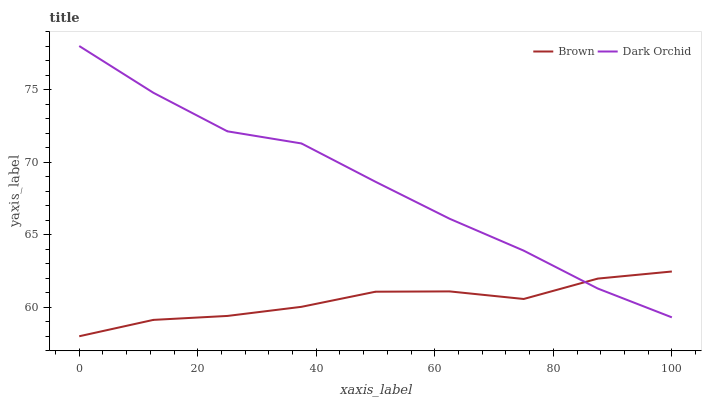Does Brown have the minimum area under the curve?
Answer yes or no. Yes. Does Dark Orchid have the maximum area under the curve?
Answer yes or no. Yes. Does Dark Orchid have the minimum area under the curve?
Answer yes or no. No. Is Dark Orchid the smoothest?
Answer yes or no. Yes. Is Brown the roughest?
Answer yes or no. Yes. Is Dark Orchid the roughest?
Answer yes or no. No. Does Brown have the lowest value?
Answer yes or no. Yes. Does Dark Orchid have the lowest value?
Answer yes or no. No. Does Dark Orchid have the highest value?
Answer yes or no. Yes. Does Brown intersect Dark Orchid?
Answer yes or no. Yes. Is Brown less than Dark Orchid?
Answer yes or no. No. Is Brown greater than Dark Orchid?
Answer yes or no. No. 